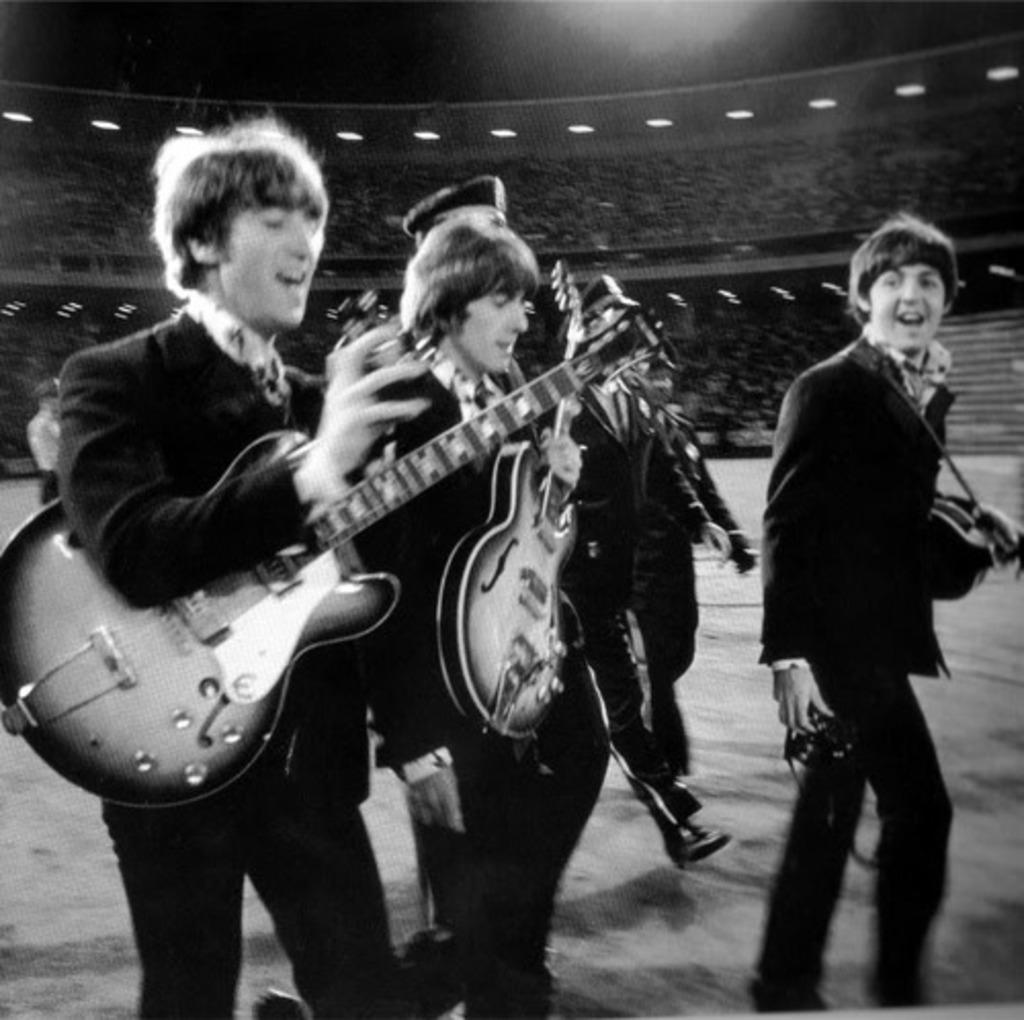What are the men in the image doing? The men in the image are playing musical instruments. Can you describe the light visible in the background of the image? Unfortunately, the facts provided do not give any details about the light in the background. However, we can confirm that there is a light visible in the background. What type of berry can be seen rolling on the floor in the image? There is no berry present in the image; it only features men playing musical instruments and a light visible in the background. 